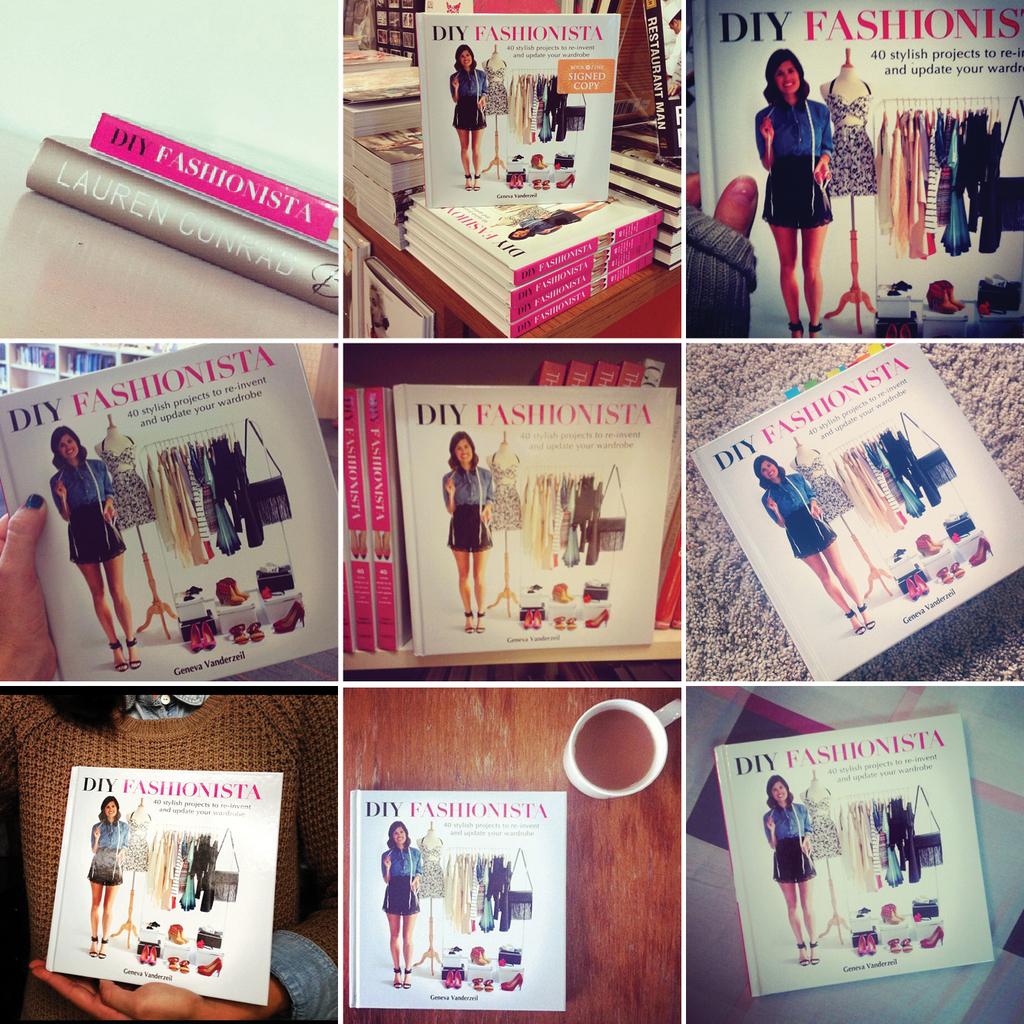What is the name of this book?
Your response must be concise. Diy fashionista. What name is on the gold book in the left picture?
Your answer should be very brief. Lauren conrad. 